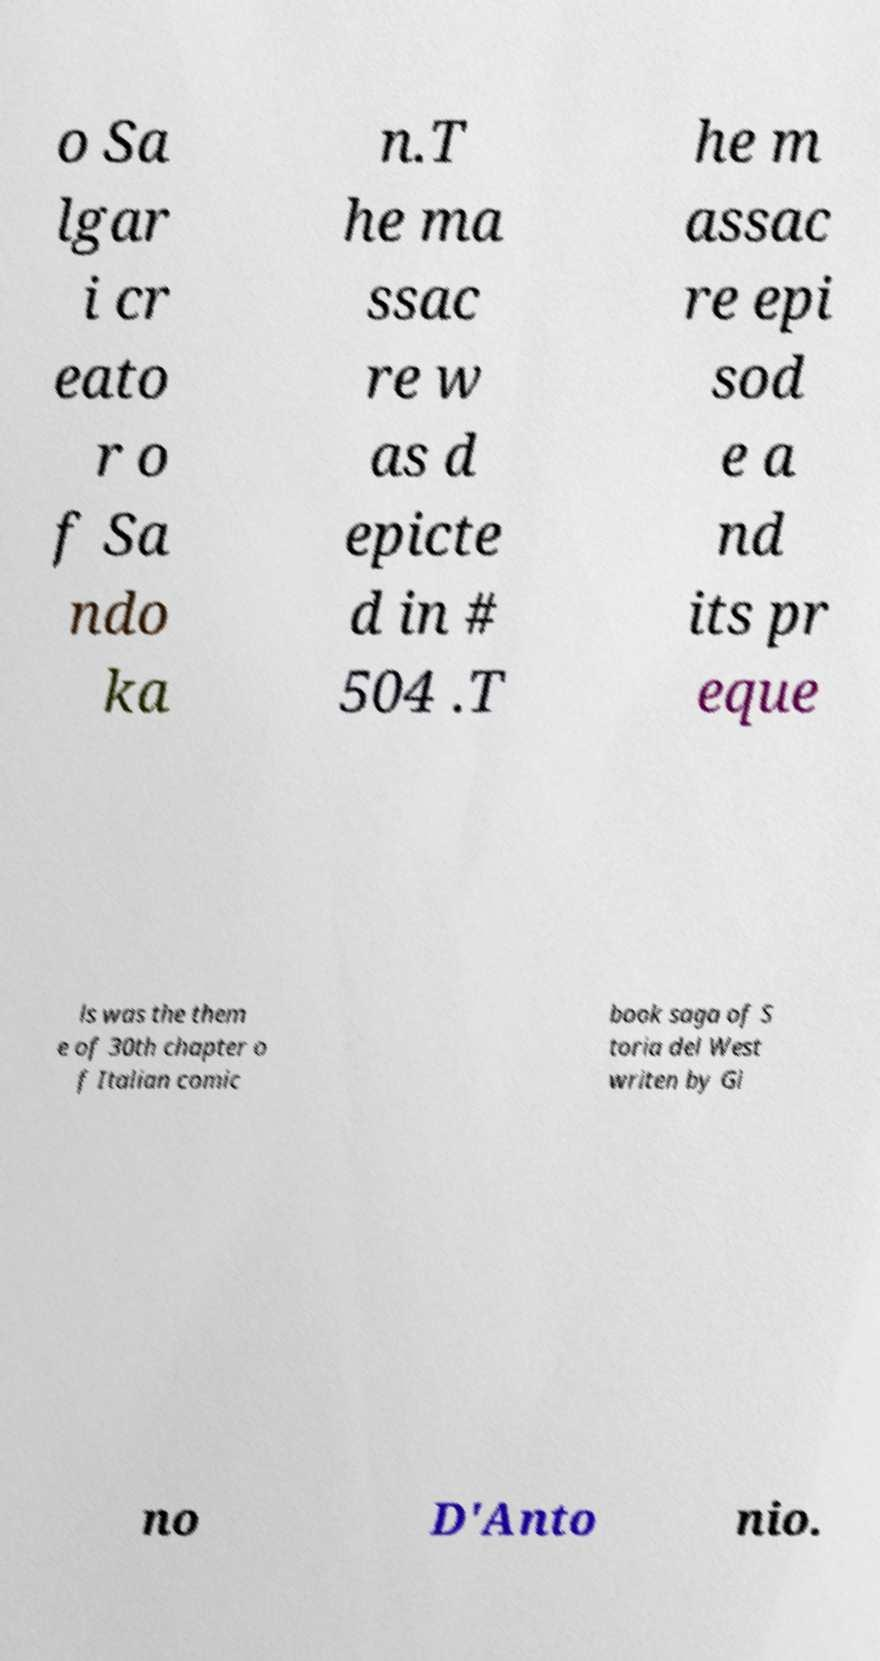Please identify and transcribe the text found in this image. o Sa lgar i cr eato r o f Sa ndo ka n.T he ma ssac re w as d epicte d in # 504 .T he m assac re epi sod e a nd its pr eque ls was the them e of 30th chapter o f Italian comic book saga of S toria del West writen by Gi no D'Anto nio. 